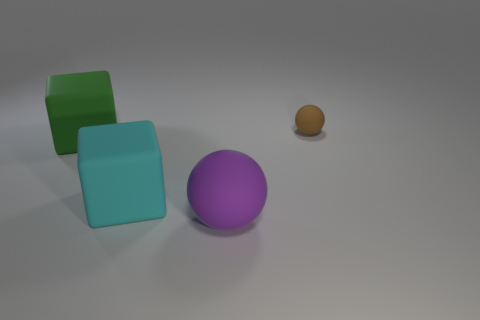Add 2 tiny matte balls. How many objects exist? 6 Add 2 tiny things. How many tiny things are left? 3 Add 4 big green rubber objects. How many big green rubber objects exist? 5 Subtract 0 yellow balls. How many objects are left? 4 Subtract all brown things. Subtract all brown metallic things. How many objects are left? 3 